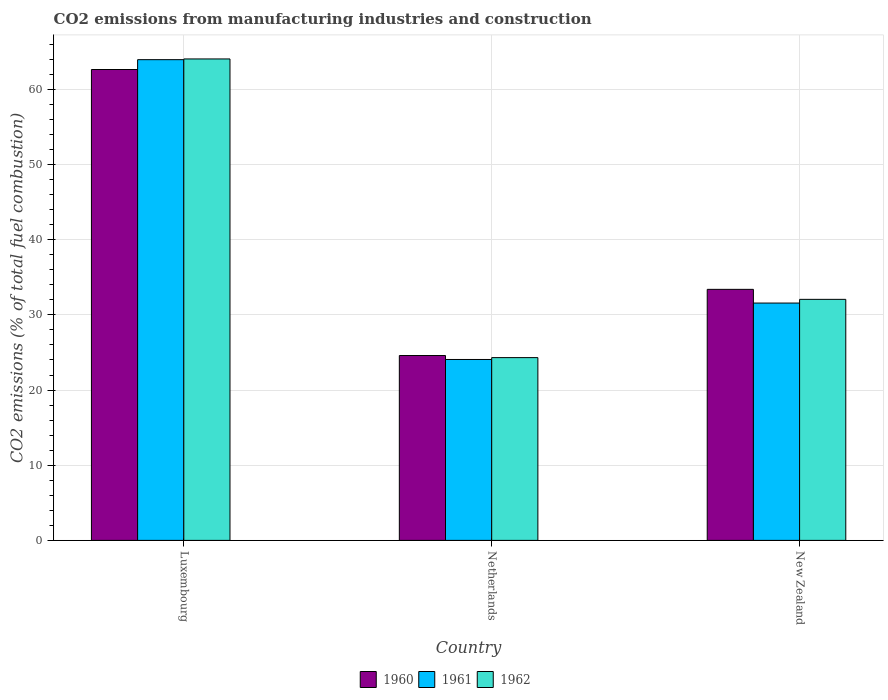How many different coloured bars are there?
Make the answer very short. 3. How many groups of bars are there?
Make the answer very short. 3. Are the number of bars per tick equal to the number of legend labels?
Give a very brief answer. Yes. Are the number of bars on each tick of the X-axis equal?
Offer a terse response. Yes. How many bars are there on the 1st tick from the right?
Provide a short and direct response. 3. What is the label of the 2nd group of bars from the left?
Your answer should be compact. Netherlands. What is the amount of CO2 emitted in 1960 in Luxembourg?
Keep it short and to the point. 62.65. Across all countries, what is the maximum amount of CO2 emitted in 1960?
Give a very brief answer. 62.65. Across all countries, what is the minimum amount of CO2 emitted in 1960?
Make the answer very short. 24.59. In which country was the amount of CO2 emitted in 1962 maximum?
Your answer should be compact. Luxembourg. In which country was the amount of CO2 emitted in 1961 minimum?
Provide a short and direct response. Netherlands. What is the total amount of CO2 emitted in 1960 in the graph?
Your response must be concise. 120.64. What is the difference between the amount of CO2 emitted in 1961 in Luxembourg and that in New Zealand?
Keep it short and to the point. 32.38. What is the difference between the amount of CO2 emitted in 1960 in New Zealand and the amount of CO2 emitted in 1961 in Luxembourg?
Your answer should be compact. -30.56. What is the average amount of CO2 emitted in 1962 per country?
Your answer should be very brief. 40.14. What is the difference between the amount of CO2 emitted of/in 1961 and amount of CO2 emitted of/in 1962 in Netherlands?
Offer a terse response. -0.25. In how many countries, is the amount of CO2 emitted in 1962 greater than 54 %?
Provide a short and direct response. 1. What is the ratio of the amount of CO2 emitted in 1960 in Netherlands to that in New Zealand?
Offer a terse response. 0.74. Is the amount of CO2 emitted in 1961 in Netherlands less than that in New Zealand?
Keep it short and to the point. Yes. What is the difference between the highest and the second highest amount of CO2 emitted in 1961?
Keep it short and to the point. -7.5. What is the difference between the highest and the lowest amount of CO2 emitted in 1962?
Give a very brief answer. 39.73. Is the sum of the amount of CO2 emitted in 1962 in Luxembourg and New Zealand greater than the maximum amount of CO2 emitted in 1960 across all countries?
Keep it short and to the point. Yes. What does the 1st bar from the left in New Zealand represents?
Provide a succinct answer. 1960. Are all the bars in the graph horizontal?
Provide a succinct answer. No. What is the difference between two consecutive major ticks on the Y-axis?
Make the answer very short. 10. Are the values on the major ticks of Y-axis written in scientific E-notation?
Provide a succinct answer. No. Does the graph contain any zero values?
Provide a short and direct response. No. Does the graph contain grids?
Your response must be concise. Yes. Where does the legend appear in the graph?
Make the answer very short. Bottom center. How are the legend labels stacked?
Provide a short and direct response. Horizontal. What is the title of the graph?
Provide a succinct answer. CO2 emissions from manufacturing industries and construction. What is the label or title of the X-axis?
Offer a terse response. Country. What is the label or title of the Y-axis?
Keep it short and to the point. CO2 emissions (% of total fuel combustion). What is the CO2 emissions (% of total fuel combustion) in 1960 in Luxembourg?
Offer a very short reply. 62.65. What is the CO2 emissions (% of total fuel combustion) in 1961 in Luxembourg?
Provide a succinct answer. 63.95. What is the CO2 emissions (% of total fuel combustion) in 1962 in Luxembourg?
Provide a succinct answer. 64.05. What is the CO2 emissions (% of total fuel combustion) in 1960 in Netherlands?
Offer a terse response. 24.59. What is the CO2 emissions (% of total fuel combustion) of 1961 in Netherlands?
Offer a very short reply. 24.07. What is the CO2 emissions (% of total fuel combustion) in 1962 in Netherlands?
Give a very brief answer. 24.32. What is the CO2 emissions (% of total fuel combustion) of 1960 in New Zealand?
Ensure brevity in your answer.  33.4. What is the CO2 emissions (% of total fuel combustion) of 1961 in New Zealand?
Offer a very short reply. 31.57. What is the CO2 emissions (% of total fuel combustion) in 1962 in New Zealand?
Offer a very short reply. 32.07. Across all countries, what is the maximum CO2 emissions (% of total fuel combustion) in 1960?
Ensure brevity in your answer.  62.65. Across all countries, what is the maximum CO2 emissions (% of total fuel combustion) of 1961?
Provide a succinct answer. 63.95. Across all countries, what is the maximum CO2 emissions (% of total fuel combustion) in 1962?
Your response must be concise. 64.05. Across all countries, what is the minimum CO2 emissions (% of total fuel combustion) of 1960?
Give a very brief answer. 24.59. Across all countries, what is the minimum CO2 emissions (% of total fuel combustion) of 1961?
Ensure brevity in your answer.  24.07. Across all countries, what is the minimum CO2 emissions (% of total fuel combustion) of 1962?
Provide a succinct answer. 24.32. What is the total CO2 emissions (% of total fuel combustion) of 1960 in the graph?
Provide a succinct answer. 120.64. What is the total CO2 emissions (% of total fuel combustion) of 1961 in the graph?
Your response must be concise. 119.6. What is the total CO2 emissions (% of total fuel combustion) of 1962 in the graph?
Give a very brief answer. 120.43. What is the difference between the CO2 emissions (% of total fuel combustion) in 1960 in Luxembourg and that in Netherlands?
Provide a succinct answer. 38.05. What is the difference between the CO2 emissions (% of total fuel combustion) in 1961 in Luxembourg and that in Netherlands?
Provide a short and direct response. 39.88. What is the difference between the CO2 emissions (% of total fuel combustion) in 1962 in Luxembourg and that in Netherlands?
Give a very brief answer. 39.73. What is the difference between the CO2 emissions (% of total fuel combustion) in 1960 in Luxembourg and that in New Zealand?
Keep it short and to the point. 29.25. What is the difference between the CO2 emissions (% of total fuel combustion) in 1961 in Luxembourg and that in New Zealand?
Keep it short and to the point. 32.38. What is the difference between the CO2 emissions (% of total fuel combustion) in 1962 in Luxembourg and that in New Zealand?
Make the answer very short. 31.98. What is the difference between the CO2 emissions (% of total fuel combustion) in 1960 in Netherlands and that in New Zealand?
Provide a short and direct response. -8.8. What is the difference between the CO2 emissions (% of total fuel combustion) in 1961 in Netherlands and that in New Zealand?
Your answer should be compact. -7.5. What is the difference between the CO2 emissions (% of total fuel combustion) of 1962 in Netherlands and that in New Zealand?
Offer a terse response. -7.75. What is the difference between the CO2 emissions (% of total fuel combustion) in 1960 in Luxembourg and the CO2 emissions (% of total fuel combustion) in 1961 in Netherlands?
Keep it short and to the point. 38.58. What is the difference between the CO2 emissions (% of total fuel combustion) in 1960 in Luxembourg and the CO2 emissions (% of total fuel combustion) in 1962 in Netherlands?
Your answer should be very brief. 38.33. What is the difference between the CO2 emissions (% of total fuel combustion) of 1961 in Luxembourg and the CO2 emissions (% of total fuel combustion) of 1962 in Netherlands?
Give a very brief answer. 39.64. What is the difference between the CO2 emissions (% of total fuel combustion) in 1960 in Luxembourg and the CO2 emissions (% of total fuel combustion) in 1961 in New Zealand?
Give a very brief answer. 31.07. What is the difference between the CO2 emissions (% of total fuel combustion) of 1960 in Luxembourg and the CO2 emissions (% of total fuel combustion) of 1962 in New Zealand?
Offer a very short reply. 30.58. What is the difference between the CO2 emissions (% of total fuel combustion) in 1961 in Luxembourg and the CO2 emissions (% of total fuel combustion) in 1962 in New Zealand?
Make the answer very short. 31.89. What is the difference between the CO2 emissions (% of total fuel combustion) in 1960 in Netherlands and the CO2 emissions (% of total fuel combustion) in 1961 in New Zealand?
Give a very brief answer. -6.98. What is the difference between the CO2 emissions (% of total fuel combustion) of 1960 in Netherlands and the CO2 emissions (% of total fuel combustion) of 1962 in New Zealand?
Your response must be concise. -7.47. What is the difference between the CO2 emissions (% of total fuel combustion) in 1961 in Netherlands and the CO2 emissions (% of total fuel combustion) in 1962 in New Zealand?
Offer a terse response. -8. What is the average CO2 emissions (% of total fuel combustion) of 1960 per country?
Offer a terse response. 40.21. What is the average CO2 emissions (% of total fuel combustion) of 1961 per country?
Ensure brevity in your answer.  39.87. What is the average CO2 emissions (% of total fuel combustion) in 1962 per country?
Ensure brevity in your answer.  40.14. What is the difference between the CO2 emissions (% of total fuel combustion) of 1960 and CO2 emissions (% of total fuel combustion) of 1961 in Luxembourg?
Offer a terse response. -1.31. What is the difference between the CO2 emissions (% of total fuel combustion) of 1960 and CO2 emissions (% of total fuel combustion) of 1962 in Luxembourg?
Make the answer very short. -1.4. What is the difference between the CO2 emissions (% of total fuel combustion) of 1961 and CO2 emissions (% of total fuel combustion) of 1962 in Luxembourg?
Ensure brevity in your answer.  -0.1. What is the difference between the CO2 emissions (% of total fuel combustion) in 1960 and CO2 emissions (% of total fuel combustion) in 1961 in Netherlands?
Your answer should be very brief. 0.52. What is the difference between the CO2 emissions (% of total fuel combustion) of 1960 and CO2 emissions (% of total fuel combustion) of 1962 in Netherlands?
Ensure brevity in your answer.  0.28. What is the difference between the CO2 emissions (% of total fuel combustion) in 1961 and CO2 emissions (% of total fuel combustion) in 1962 in Netherlands?
Your answer should be very brief. -0.25. What is the difference between the CO2 emissions (% of total fuel combustion) of 1960 and CO2 emissions (% of total fuel combustion) of 1961 in New Zealand?
Provide a short and direct response. 1.82. What is the difference between the CO2 emissions (% of total fuel combustion) in 1960 and CO2 emissions (% of total fuel combustion) in 1962 in New Zealand?
Offer a terse response. 1.33. What is the difference between the CO2 emissions (% of total fuel combustion) of 1961 and CO2 emissions (% of total fuel combustion) of 1962 in New Zealand?
Provide a succinct answer. -0.49. What is the ratio of the CO2 emissions (% of total fuel combustion) of 1960 in Luxembourg to that in Netherlands?
Provide a short and direct response. 2.55. What is the ratio of the CO2 emissions (% of total fuel combustion) in 1961 in Luxembourg to that in Netherlands?
Keep it short and to the point. 2.66. What is the ratio of the CO2 emissions (% of total fuel combustion) of 1962 in Luxembourg to that in Netherlands?
Offer a terse response. 2.63. What is the ratio of the CO2 emissions (% of total fuel combustion) of 1960 in Luxembourg to that in New Zealand?
Your answer should be compact. 1.88. What is the ratio of the CO2 emissions (% of total fuel combustion) in 1961 in Luxembourg to that in New Zealand?
Offer a very short reply. 2.03. What is the ratio of the CO2 emissions (% of total fuel combustion) in 1962 in Luxembourg to that in New Zealand?
Ensure brevity in your answer.  2. What is the ratio of the CO2 emissions (% of total fuel combustion) of 1960 in Netherlands to that in New Zealand?
Your response must be concise. 0.74. What is the ratio of the CO2 emissions (% of total fuel combustion) in 1961 in Netherlands to that in New Zealand?
Ensure brevity in your answer.  0.76. What is the ratio of the CO2 emissions (% of total fuel combustion) of 1962 in Netherlands to that in New Zealand?
Give a very brief answer. 0.76. What is the difference between the highest and the second highest CO2 emissions (% of total fuel combustion) in 1960?
Ensure brevity in your answer.  29.25. What is the difference between the highest and the second highest CO2 emissions (% of total fuel combustion) in 1961?
Your answer should be compact. 32.38. What is the difference between the highest and the second highest CO2 emissions (% of total fuel combustion) in 1962?
Offer a very short reply. 31.98. What is the difference between the highest and the lowest CO2 emissions (% of total fuel combustion) in 1960?
Provide a short and direct response. 38.05. What is the difference between the highest and the lowest CO2 emissions (% of total fuel combustion) in 1961?
Provide a succinct answer. 39.88. What is the difference between the highest and the lowest CO2 emissions (% of total fuel combustion) of 1962?
Offer a terse response. 39.73. 